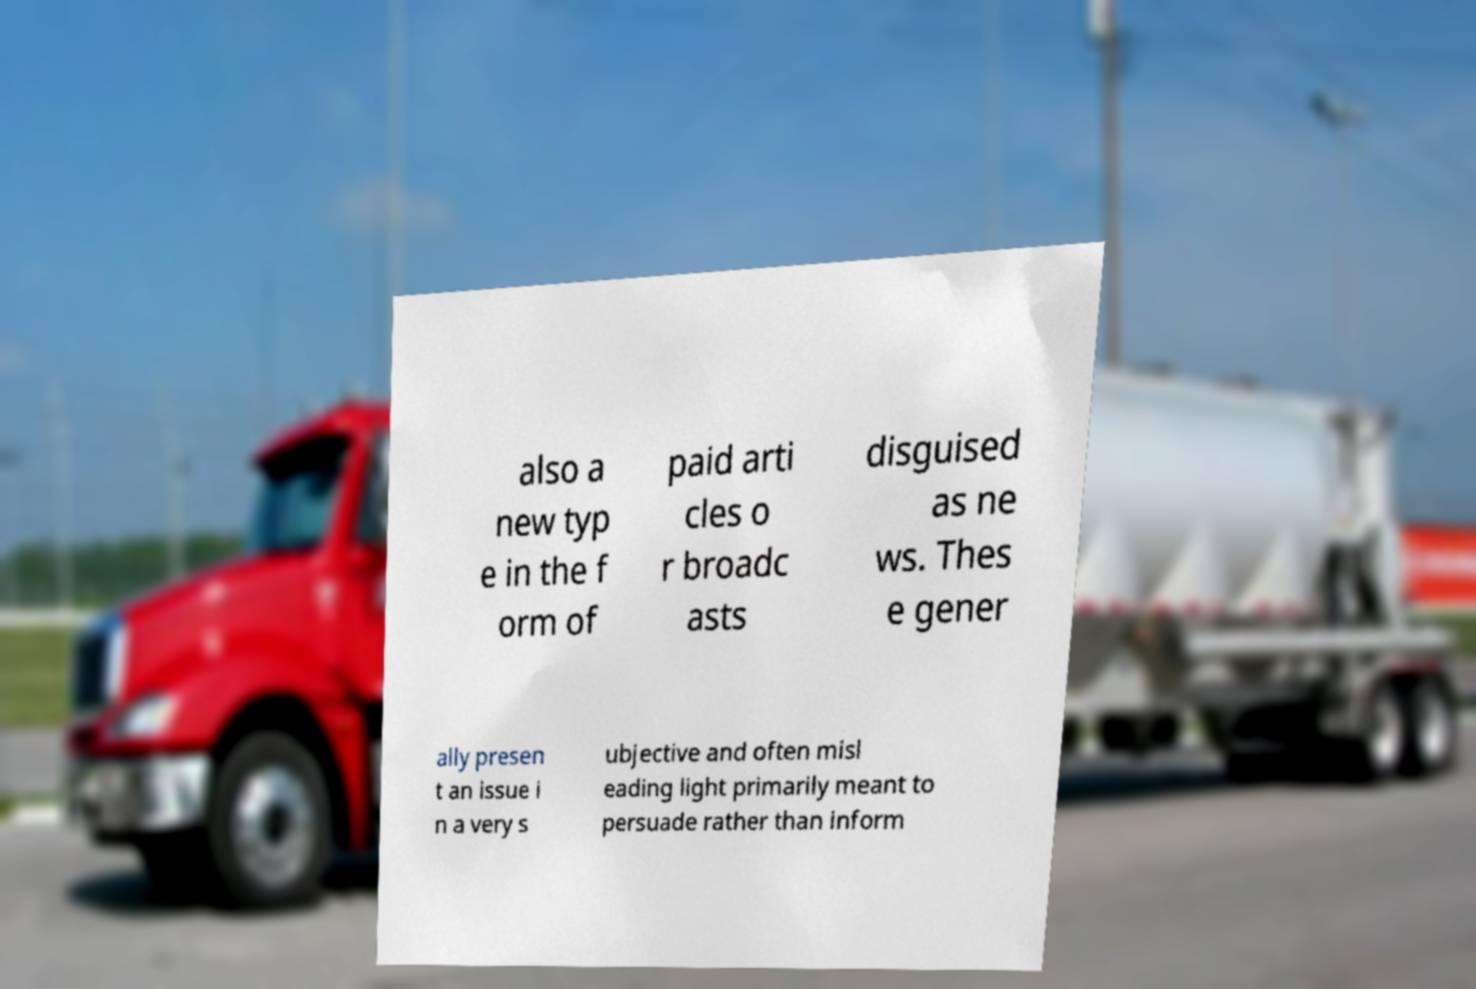I need the written content from this picture converted into text. Can you do that? also a new typ e in the f orm of paid arti cles o r broadc asts disguised as ne ws. Thes e gener ally presen t an issue i n a very s ubjective and often misl eading light primarily meant to persuade rather than inform 